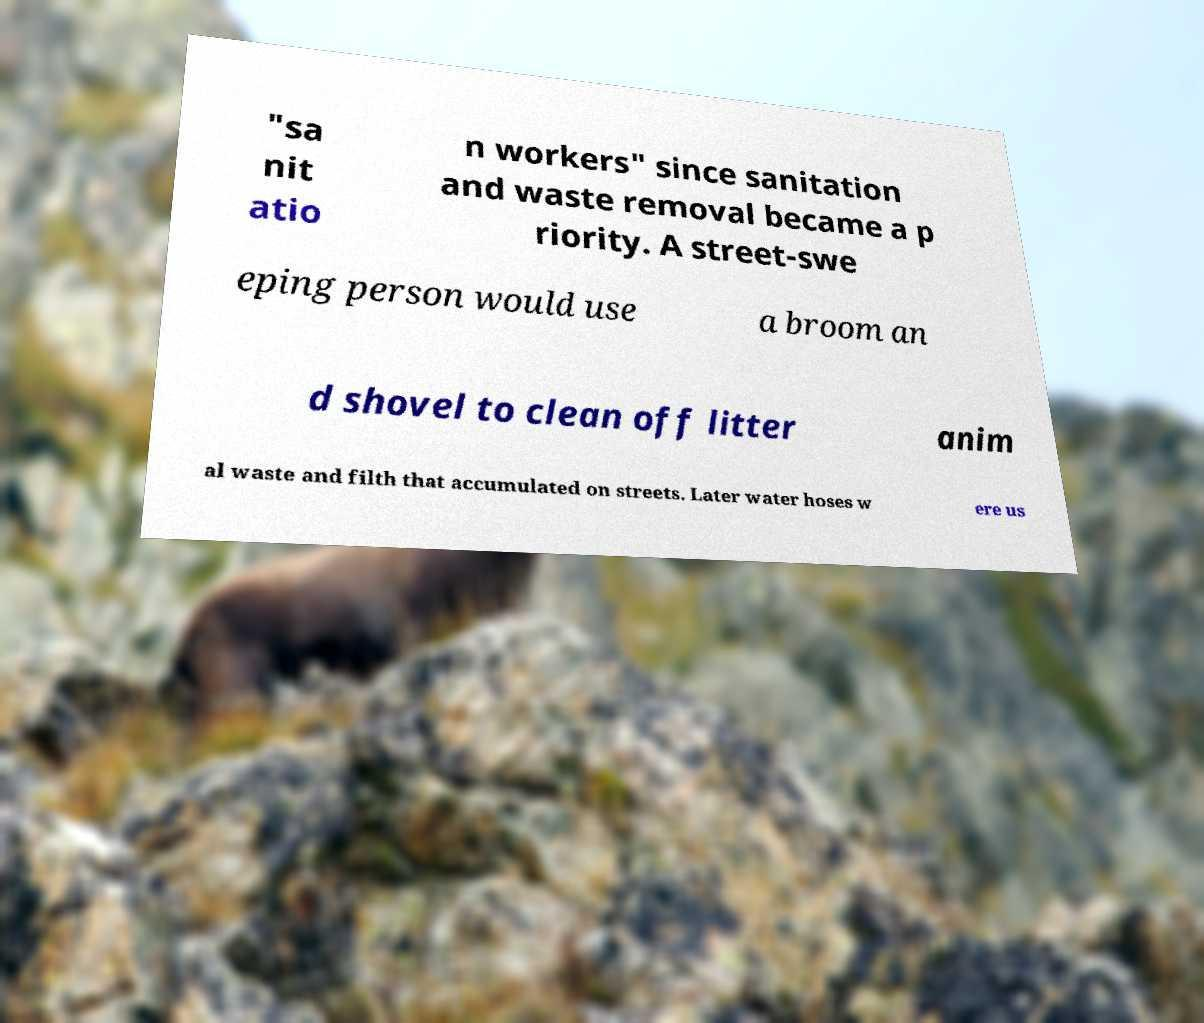I need the written content from this picture converted into text. Can you do that? "sa nit atio n workers" since sanitation and waste removal became a p riority. A street-swe eping person would use a broom an d shovel to clean off litter anim al waste and filth that accumulated on streets. Later water hoses w ere us 